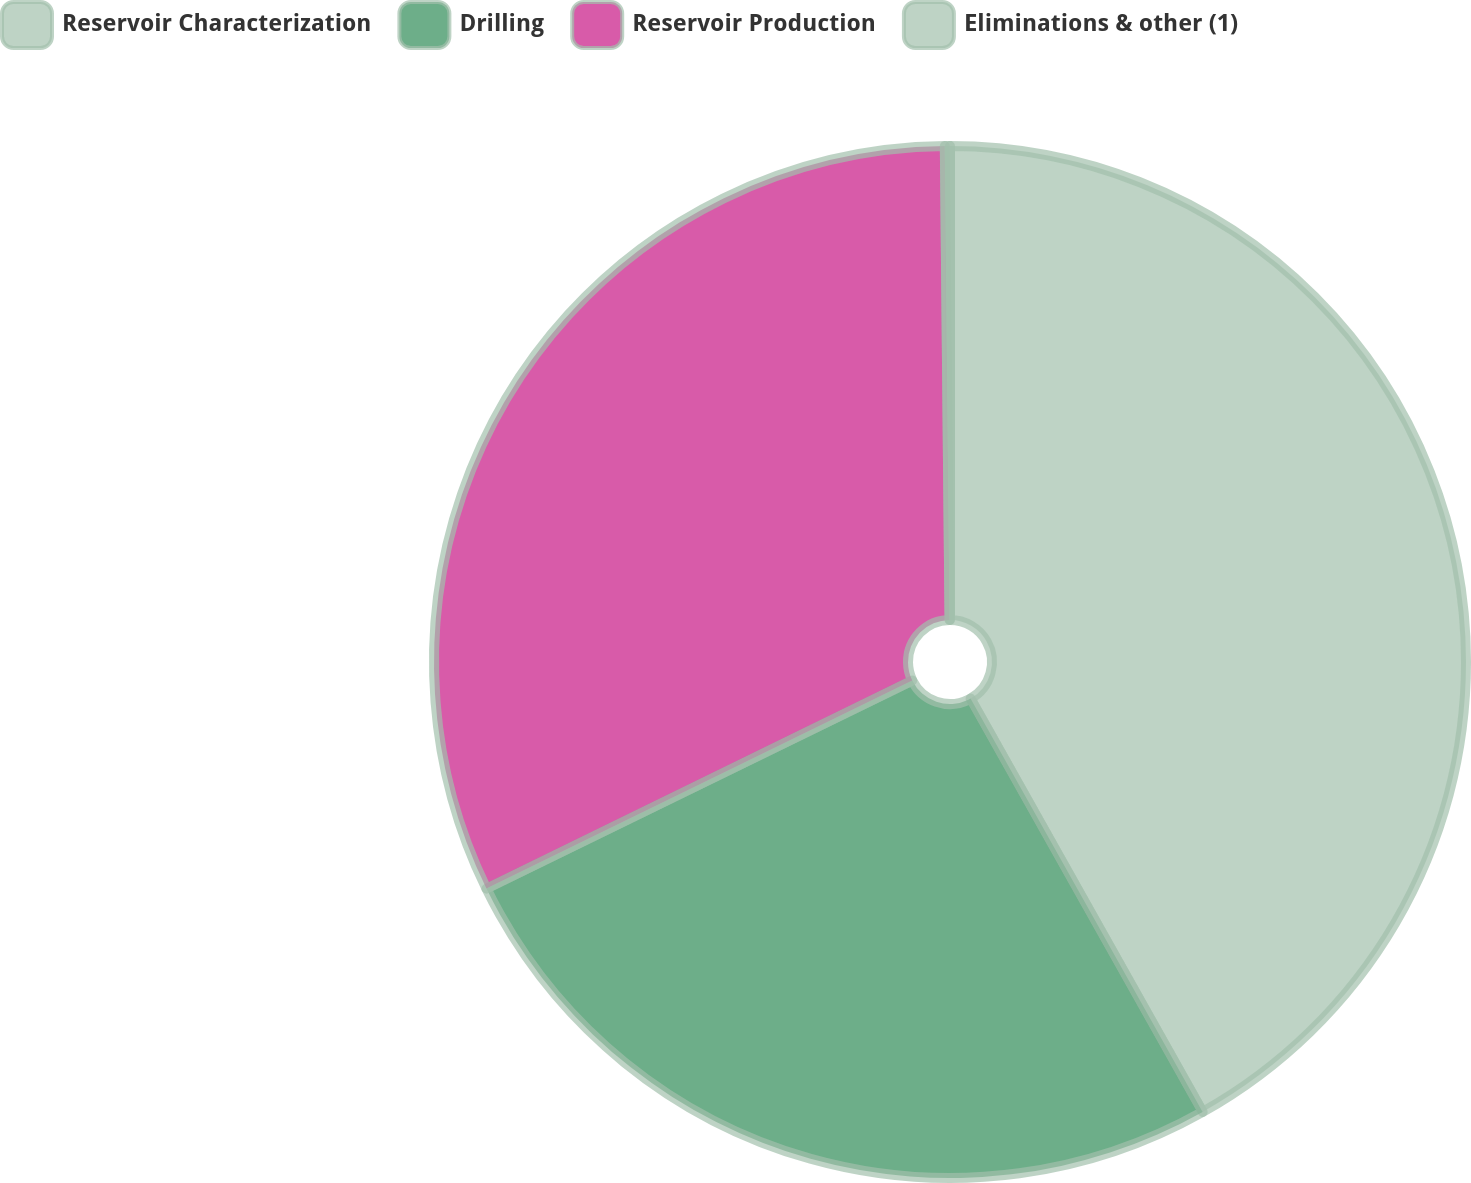Convert chart. <chart><loc_0><loc_0><loc_500><loc_500><pie_chart><fcel>Reservoir Characterization<fcel>Drilling<fcel>Reservoir Production<fcel>Eliminations & other (1)<nl><fcel>41.86%<fcel>25.91%<fcel>32.08%<fcel>0.16%<nl></chart> 